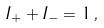<formula> <loc_0><loc_0><loc_500><loc_500>I _ { + } + I _ { - } = 1 \, ,</formula> 